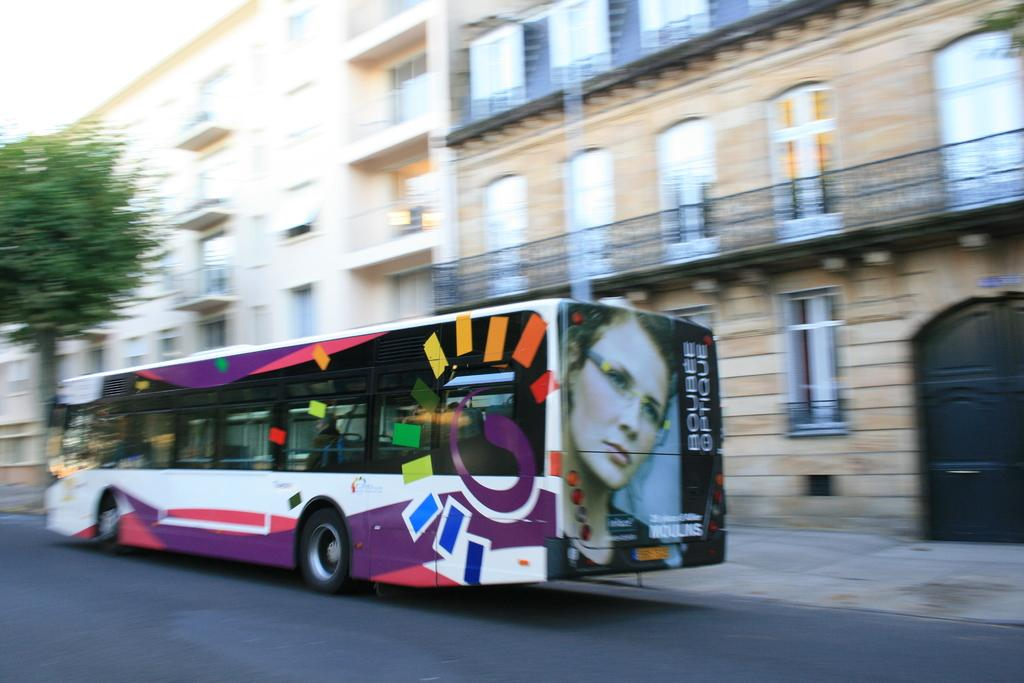What type of vehicle is on the road in the image? There is a bus on the road in the image. What else can be seen in the image besides the bus? There are buildings and a tree visible in the image. What type of bottle is being used to produce the tree in the image? There is no bottle or production process depicted in the image; the tree is a natural element. 